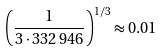<formula> <loc_0><loc_0><loc_500><loc_500>\left ( { \frac { 1 } { 3 \cdot 3 3 2 \, 9 4 6 } } \right ) ^ { 1 / 3 } \approx 0 . 0 1</formula> 